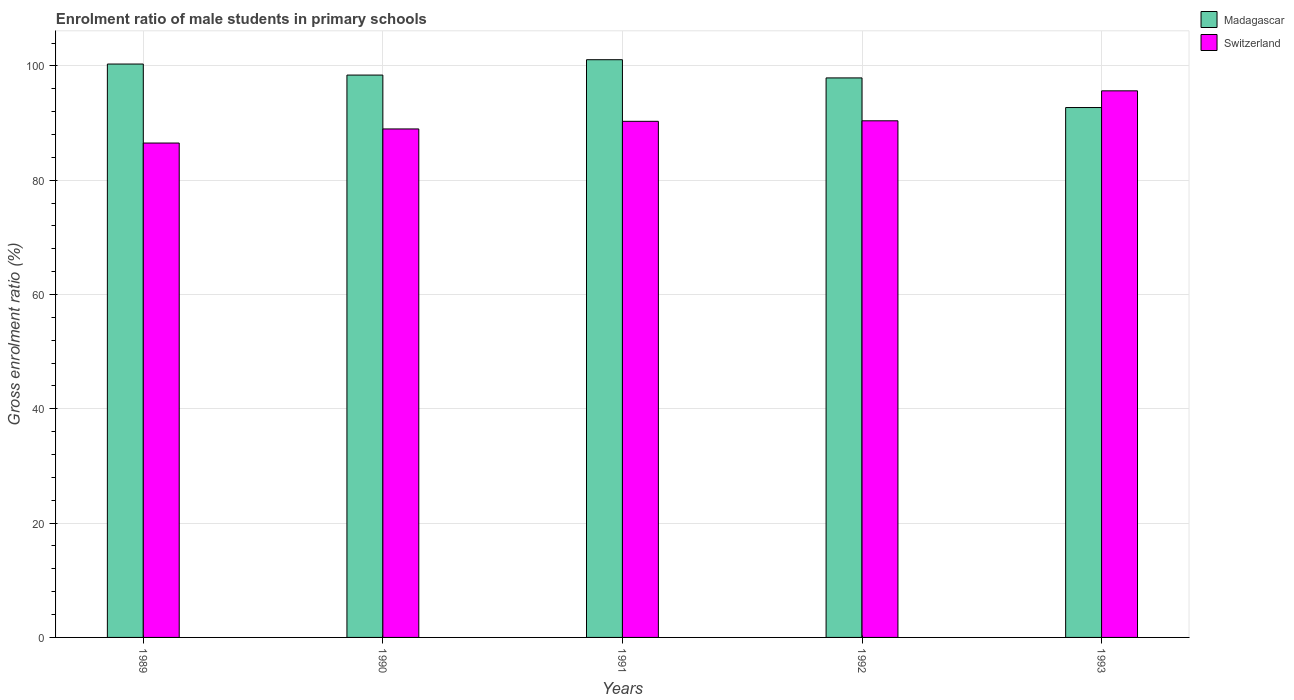How many different coloured bars are there?
Provide a short and direct response. 2. Are the number of bars per tick equal to the number of legend labels?
Give a very brief answer. Yes. In how many cases, is the number of bars for a given year not equal to the number of legend labels?
Give a very brief answer. 0. What is the enrolment ratio of male students in primary schools in Switzerland in 1992?
Offer a terse response. 90.41. Across all years, what is the maximum enrolment ratio of male students in primary schools in Switzerland?
Make the answer very short. 95.65. Across all years, what is the minimum enrolment ratio of male students in primary schools in Madagascar?
Offer a terse response. 92.73. In which year was the enrolment ratio of male students in primary schools in Switzerland maximum?
Give a very brief answer. 1993. In which year was the enrolment ratio of male students in primary schools in Madagascar minimum?
Keep it short and to the point. 1993. What is the total enrolment ratio of male students in primary schools in Switzerland in the graph?
Offer a very short reply. 451.87. What is the difference between the enrolment ratio of male students in primary schools in Madagascar in 1991 and that in 1992?
Keep it short and to the point. 3.19. What is the difference between the enrolment ratio of male students in primary schools in Switzerland in 1991 and the enrolment ratio of male students in primary schools in Madagascar in 1990?
Offer a terse response. -8.09. What is the average enrolment ratio of male students in primary schools in Switzerland per year?
Give a very brief answer. 90.37. In the year 1992, what is the difference between the enrolment ratio of male students in primary schools in Switzerland and enrolment ratio of male students in primary schools in Madagascar?
Make the answer very short. -7.5. What is the ratio of the enrolment ratio of male students in primary schools in Switzerland in 1992 to that in 1993?
Provide a short and direct response. 0.95. Is the enrolment ratio of male students in primary schools in Madagascar in 1989 less than that in 1992?
Provide a short and direct response. No. What is the difference between the highest and the second highest enrolment ratio of male students in primary schools in Madagascar?
Offer a very short reply. 0.76. What is the difference between the highest and the lowest enrolment ratio of male students in primary schools in Madagascar?
Give a very brief answer. 8.37. Is the sum of the enrolment ratio of male students in primary schools in Switzerland in 1989 and 1990 greater than the maximum enrolment ratio of male students in primary schools in Madagascar across all years?
Give a very brief answer. Yes. What does the 1st bar from the left in 1990 represents?
Keep it short and to the point. Madagascar. What does the 2nd bar from the right in 1993 represents?
Provide a succinct answer. Madagascar. Are all the bars in the graph horizontal?
Provide a succinct answer. No. Are the values on the major ticks of Y-axis written in scientific E-notation?
Your answer should be compact. No. Does the graph contain any zero values?
Offer a terse response. No. Where does the legend appear in the graph?
Offer a very short reply. Top right. What is the title of the graph?
Make the answer very short. Enrolment ratio of male students in primary schools. What is the label or title of the X-axis?
Provide a succinct answer. Years. What is the Gross enrolment ratio (%) in Madagascar in 1989?
Provide a short and direct response. 100.34. What is the Gross enrolment ratio (%) of Switzerland in 1989?
Your answer should be compact. 86.51. What is the Gross enrolment ratio (%) of Madagascar in 1990?
Your answer should be compact. 98.41. What is the Gross enrolment ratio (%) in Switzerland in 1990?
Keep it short and to the point. 88.98. What is the Gross enrolment ratio (%) in Madagascar in 1991?
Offer a very short reply. 101.1. What is the Gross enrolment ratio (%) of Switzerland in 1991?
Keep it short and to the point. 90.32. What is the Gross enrolment ratio (%) in Madagascar in 1992?
Offer a terse response. 97.91. What is the Gross enrolment ratio (%) of Switzerland in 1992?
Ensure brevity in your answer.  90.41. What is the Gross enrolment ratio (%) of Madagascar in 1993?
Offer a very short reply. 92.73. What is the Gross enrolment ratio (%) in Switzerland in 1993?
Make the answer very short. 95.65. Across all years, what is the maximum Gross enrolment ratio (%) in Madagascar?
Give a very brief answer. 101.1. Across all years, what is the maximum Gross enrolment ratio (%) in Switzerland?
Your answer should be compact. 95.65. Across all years, what is the minimum Gross enrolment ratio (%) of Madagascar?
Your response must be concise. 92.73. Across all years, what is the minimum Gross enrolment ratio (%) in Switzerland?
Give a very brief answer. 86.51. What is the total Gross enrolment ratio (%) of Madagascar in the graph?
Provide a succinct answer. 490.49. What is the total Gross enrolment ratio (%) in Switzerland in the graph?
Offer a terse response. 451.87. What is the difference between the Gross enrolment ratio (%) of Madagascar in 1989 and that in 1990?
Your response must be concise. 1.93. What is the difference between the Gross enrolment ratio (%) of Switzerland in 1989 and that in 1990?
Your response must be concise. -2.47. What is the difference between the Gross enrolment ratio (%) in Madagascar in 1989 and that in 1991?
Provide a short and direct response. -0.76. What is the difference between the Gross enrolment ratio (%) in Switzerland in 1989 and that in 1991?
Provide a succinct answer. -3.8. What is the difference between the Gross enrolment ratio (%) of Madagascar in 1989 and that in 1992?
Ensure brevity in your answer.  2.43. What is the difference between the Gross enrolment ratio (%) of Switzerland in 1989 and that in 1992?
Offer a very short reply. -3.89. What is the difference between the Gross enrolment ratio (%) in Madagascar in 1989 and that in 1993?
Make the answer very short. 7.61. What is the difference between the Gross enrolment ratio (%) of Switzerland in 1989 and that in 1993?
Keep it short and to the point. -9.14. What is the difference between the Gross enrolment ratio (%) of Madagascar in 1990 and that in 1991?
Make the answer very short. -2.69. What is the difference between the Gross enrolment ratio (%) of Switzerland in 1990 and that in 1991?
Offer a very short reply. -1.34. What is the difference between the Gross enrolment ratio (%) in Madagascar in 1990 and that in 1992?
Provide a succinct answer. 0.5. What is the difference between the Gross enrolment ratio (%) in Switzerland in 1990 and that in 1992?
Your answer should be very brief. -1.43. What is the difference between the Gross enrolment ratio (%) in Madagascar in 1990 and that in 1993?
Your answer should be compact. 5.68. What is the difference between the Gross enrolment ratio (%) in Switzerland in 1990 and that in 1993?
Offer a very short reply. -6.67. What is the difference between the Gross enrolment ratio (%) of Madagascar in 1991 and that in 1992?
Ensure brevity in your answer.  3.19. What is the difference between the Gross enrolment ratio (%) in Switzerland in 1991 and that in 1992?
Your answer should be very brief. -0.09. What is the difference between the Gross enrolment ratio (%) in Madagascar in 1991 and that in 1993?
Provide a succinct answer. 8.37. What is the difference between the Gross enrolment ratio (%) of Switzerland in 1991 and that in 1993?
Give a very brief answer. -5.34. What is the difference between the Gross enrolment ratio (%) in Madagascar in 1992 and that in 1993?
Your answer should be compact. 5.18. What is the difference between the Gross enrolment ratio (%) of Switzerland in 1992 and that in 1993?
Provide a succinct answer. -5.24. What is the difference between the Gross enrolment ratio (%) in Madagascar in 1989 and the Gross enrolment ratio (%) in Switzerland in 1990?
Give a very brief answer. 11.36. What is the difference between the Gross enrolment ratio (%) of Madagascar in 1989 and the Gross enrolment ratio (%) of Switzerland in 1991?
Keep it short and to the point. 10.02. What is the difference between the Gross enrolment ratio (%) in Madagascar in 1989 and the Gross enrolment ratio (%) in Switzerland in 1992?
Provide a succinct answer. 9.93. What is the difference between the Gross enrolment ratio (%) of Madagascar in 1989 and the Gross enrolment ratio (%) of Switzerland in 1993?
Keep it short and to the point. 4.69. What is the difference between the Gross enrolment ratio (%) in Madagascar in 1990 and the Gross enrolment ratio (%) in Switzerland in 1991?
Offer a terse response. 8.09. What is the difference between the Gross enrolment ratio (%) of Madagascar in 1990 and the Gross enrolment ratio (%) of Switzerland in 1992?
Your answer should be very brief. 8. What is the difference between the Gross enrolment ratio (%) in Madagascar in 1990 and the Gross enrolment ratio (%) in Switzerland in 1993?
Your response must be concise. 2.76. What is the difference between the Gross enrolment ratio (%) in Madagascar in 1991 and the Gross enrolment ratio (%) in Switzerland in 1992?
Your answer should be very brief. 10.69. What is the difference between the Gross enrolment ratio (%) in Madagascar in 1991 and the Gross enrolment ratio (%) in Switzerland in 1993?
Give a very brief answer. 5.45. What is the difference between the Gross enrolment ratio (%) in Madagascar in 1992 and the Gross enrolment ratio (%) in Switzerland in 1993?
Provide a short and direct response. 2.26. What is the average Gross enrolment ratio (%) of Madagascar per year?
Give a very brief answer. 98.1. What is the average Gross enrolment ratio (%) of Switzerland per year?
Your answer should be very brief. 90.37. In the year 1989, what is the difference between the Gross enrolment ratio (%) in Madagascar and Gross enrolment ratio (%) in Switzerland?
Your answer should be compact. 13.83. In the year 1990, what is the difference between the Gross enrolment ratio (%) of Madagascar and Gross enrolment ratio (%) of Switzerland?
Your answer should be very brief. 9.43. In the year 1991, what is the difference between the Gross enrolment ratio (%) of Madagascar and Gross enrolment ratio (%) of Switzerland?
Offer a terse response. 10.78. In the year 1992, what is the difference between the Gross enrolment ratio (%) in Madagascar and Gross enrolment ratio (%) in Switzerland?
Provide a short and direct response. 7.5. In the year 1993, what is the difference between the Gross enrolment ratio (%) in Madagascar and Gross enrolment ratio (%) in Switzerland?
Your response must be concise. -2.92. What is the ratio of the Gross enrolment ratio (%) in Madagascar in 1989 to that in 1990?
Offer a terse response. 1.02. What is the ratio of the Gross enrolment ratio (%) in Switzerland in 1989 to that in 1990?
Provide a succinct answer. 0.97. What is the ratio of the Gross enrolment ratio (%) in Madagascar in 1989 to that in 1991?
Make the answer very short. 0.99. What is the ratio of the Gross enrolment ratio (%) of Switzerland in 1989 to that in 1991?
Ensure brevity in your answer.  0.96. What is the ratio of the Gross enrolment ratio (%) of Madagascar in 1989 to that in 1992?
Offer a terse response. 1.02. What is the ratio of the Gross enrolment ratio (%) in Switzerland in 1989 to that in 1992?
Offer a very short reply. 0.96. What is the ratio of the Gross enrolment ratio (%) in Madagascar in 1989 to that in 1993?
Your answer should be very brief. 1.08. What is the ratio of the Gross enrolment ratio (%) in Switzerland in 1989 to that in 1993?
Your answer should be compact. 0.9. What is the ratio of the Gross enrolment ratio (%) of Madagascar in 1990 to that in 1991?
Your answer should be very brief. 0.97. What is the ratio of the Gross enrolment ratio (%) in Switzerland in 1990 to that in 1991?
Offer a very short reply. 0.99. What is the ratio of the Gross enrolment ratio (%) of Switzerland in 1990 to that in 1992?
Provide a succinct answer. 0.98. What is the ratio of the Gross enrolment ratio (%) of Madagascar in 1990 to that in 1993?
Offer a terse response. 1.06. What is the ratio of the Gross enrolment ratio (%) of Switzerland in 1990 to that in 1993?
Your response must be concise. 0.93. What is the ratio of the Gross enrolment ratio (%) of Madagascar in 1991 to that in 1992?
Your answer should be very brief. 1.03. What is the ratio of the Gross enrolment ratio (%) in Madagascar in 1991 to that in 1993?
Offer a very short reply. 1.09. What is the ratio of the Gross enrolment ratio (%) of Switzerland in 1991 to that in 1993?
Ensure brevity in your answer.  0.94. What is the ratio of the Gross enrolment ratio (%) in Madagascar in 1992 to that in 1993?
Your answer should be compact. 1.06. What is the ratio of the Gross enrolment ratio (%) of Switzerland in 1992 to that in 1993?
Make the answer very short. 0.95. What is the difference between the highest and the second highest Gross enrolment ratio (%) of Madagascar?
Make the answer very short. 0.76. What is the difference between the highest and the second highest Gross enrolment ratio (%) in Switzerland?
Your answer should be compact. 5.24. What is the difference between the highest and the lowest Gross enrolment ratio (%) of Madagascar?
Offer a very short reply. 8.37. What is the difference between the highest and the lowest Gross enrolment ratio (%) in Switzerland?
Provide a succinct answer. 9.14. 